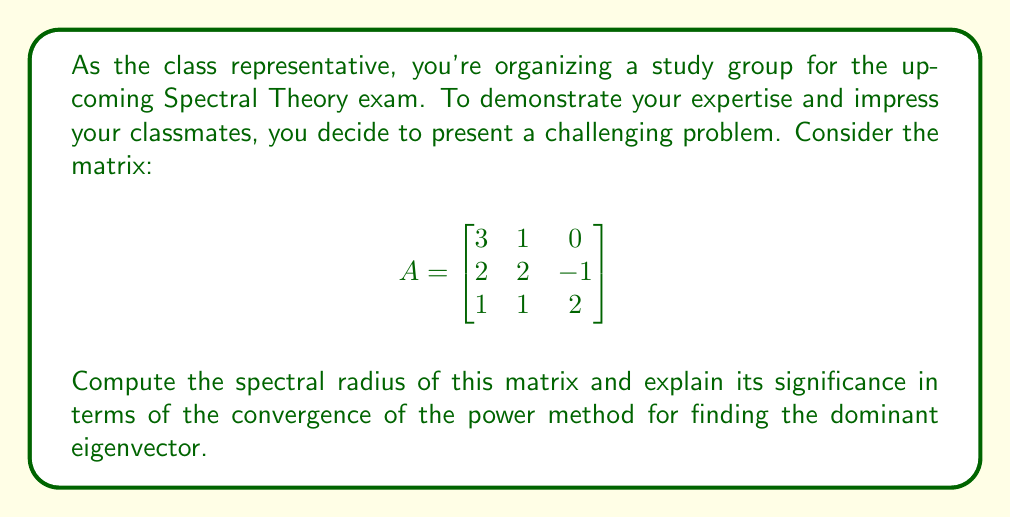Provide a solution to this math problem. To solve this problem, we'll follow these steps:

1) First, we need to find the eigenvalues of the matrix A. The characteristic equation is:

   $$det(A - \lambda I) = \begin{vmatrix}
   3-\lambda & 1 & 0 \\
   2 & 2-\lambda & -1 \\
   1 & 1 & 2-\lambda
   \end{vmatrix} = 0$$

2) Expanding this determinant:

   $(3-\lambda)((2-\lambda)(2-\lambda) + 1) - 1(2(2-\lambda) + 1) + 0 = 0$
   
   $(3-\lambda)(4-4\lambda+\lambda^2+1) - (4-2\lambda+1) = 0$
   
   $(3-\lambda)(5-4\lambda+\lambda^2) - 5 + 2\lambda = 0$
   
   $15-12\lambda+3\lambda^2-5\lambda+4\lambda^2-\lambda^3-5+2\lambda = 0$
   
   $-\lambda^3+7\lambda^2-15\lambda+10 = 0$

3) This cubic equation can be factored as:

   $-(\lambda-5)(\lambda-1)(\lambda-2) = 0$

4) Therefore, the eigenvalues are $\lambda_1 = 5$, $\lambda_2 = 1$, and $\lambda_3 = 2$.

5) The spectral radius $\rho(A)$ is the maximum absolute value of the eigenvalues:

   $\rho(A) = \max\{|\lambda_1|, |\lambda_2|, |\lambda_3|\} = \max\{5, 1, 2\} = 5$

6) The significance of the spectral radius in terms of the power method:

   - The power method converges to the dominant eigenvector if and only if there is a unique eigenvalue with the largest absolute value.
   - The rate of convergence depends on the ratio of the second largest eigenvalue (in absolute value) to the largest.
   - In this case, $\frac{|\lambda_2|}{\lambda_1} = \frac{2}{5}$, which determines the convergence rate.
   - The smaller this ratio, the faster the convergence.
Answer: $\rho(A) = 5$; Ensures power method convergence with rate $\approx \frac{2}{5}$ per iteration. 